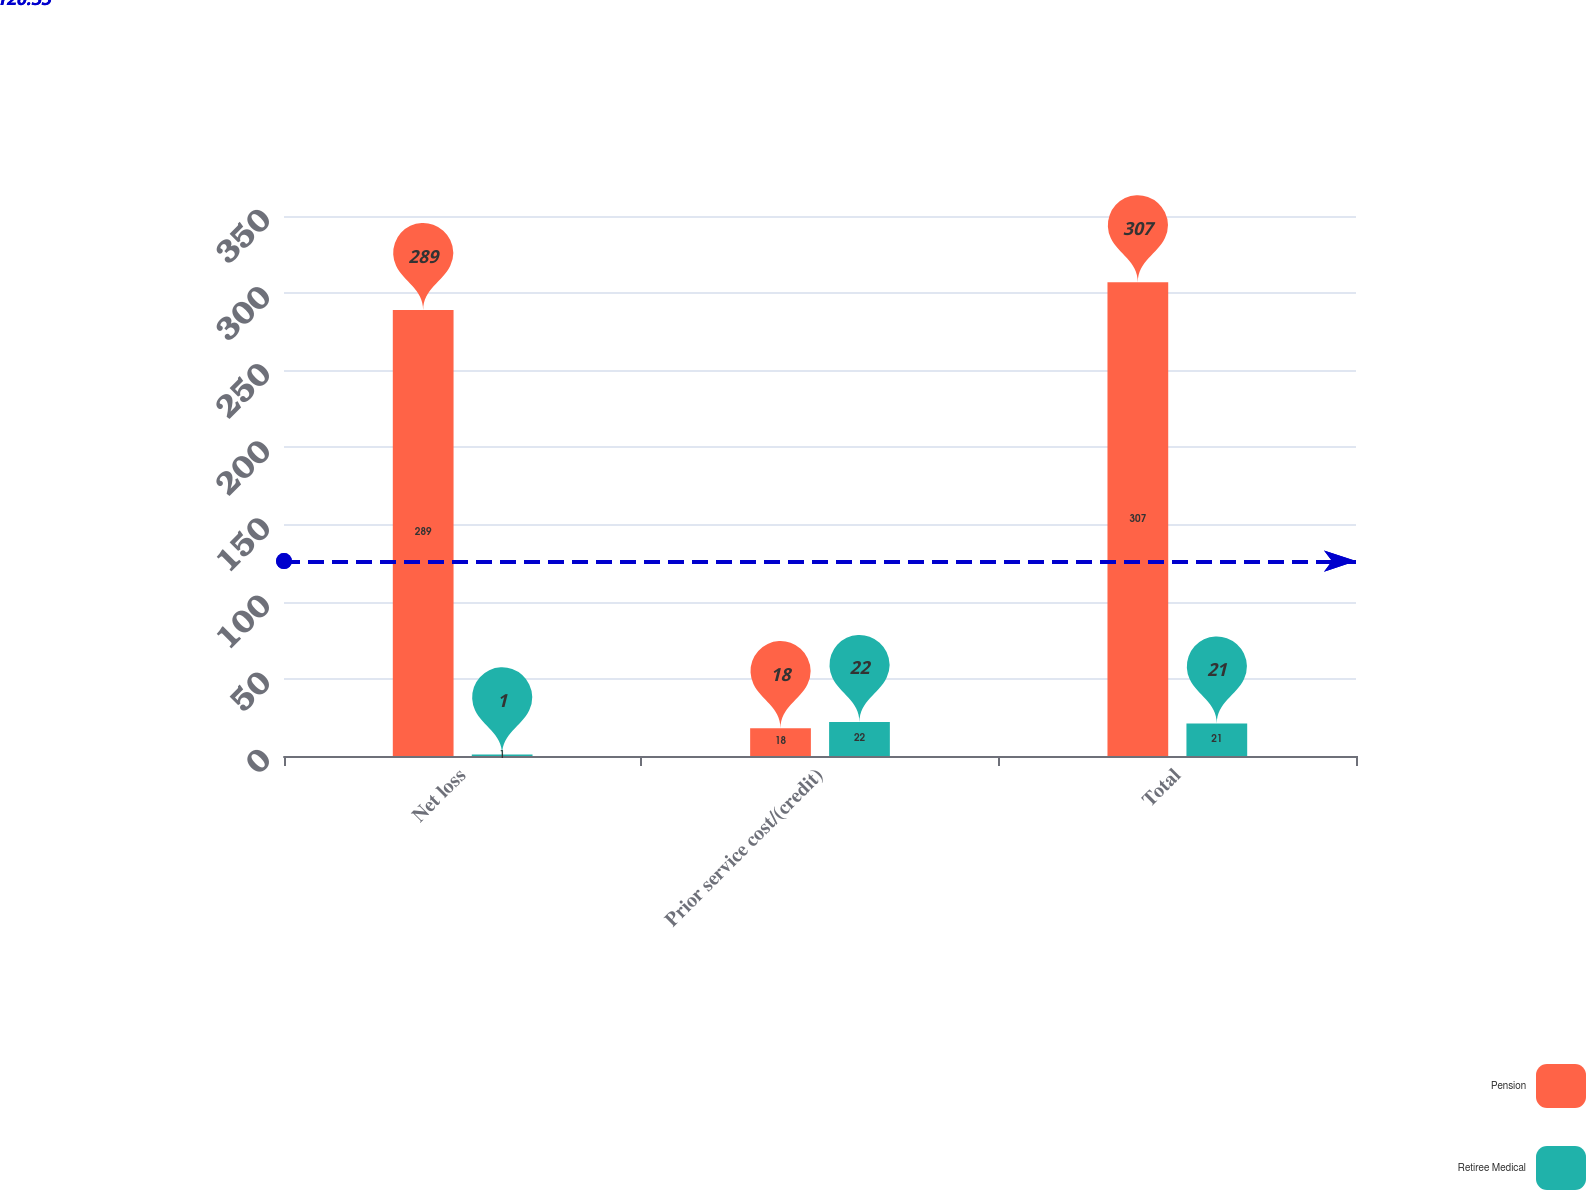<chart> <loc_0><loc_0><loc_500><loc_500><stacked_bar_chart><ecel><fcel>Net loss<fcel>Prior service cost/(credit)<fcel>Total<nl><fcel>Pension<fcel>289<fcel>18<fcel>307<nl><fcel>Retiree Medical<fcel>1<fcel>22<fcel>21<nl></chart> 